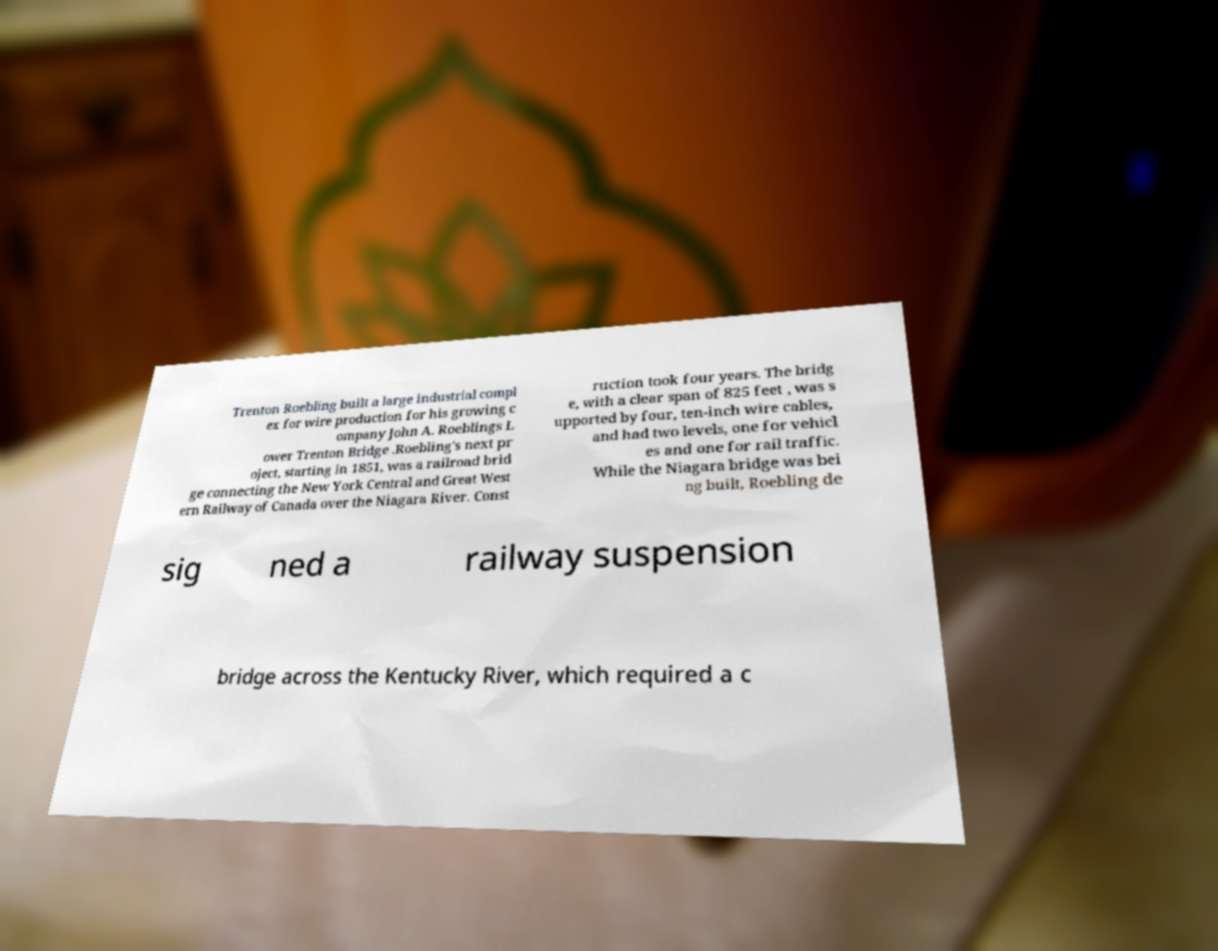Please identify and transcribe the text found in this image. Trenton Roebling built a large industrial compl ex for wire production for his growing c ompany John A. Roeblings L ower Trenton Bridge .Roebling's next pr oject, starting in 1851, was a railroad brid ge connecting the New York Central and Great West ern Railway of Canada over the Niagara River. Const ruction took four years. The bridg e, with a clear span of 825 feet , was s upported by four, ten-inch wire cables, and had two levels, one for vehicl es and one for rail traffic. While the Niagara bridge was bei ng built, Roebling de sig ned a railway suspension bridge across the Kentucky River, which required a c 